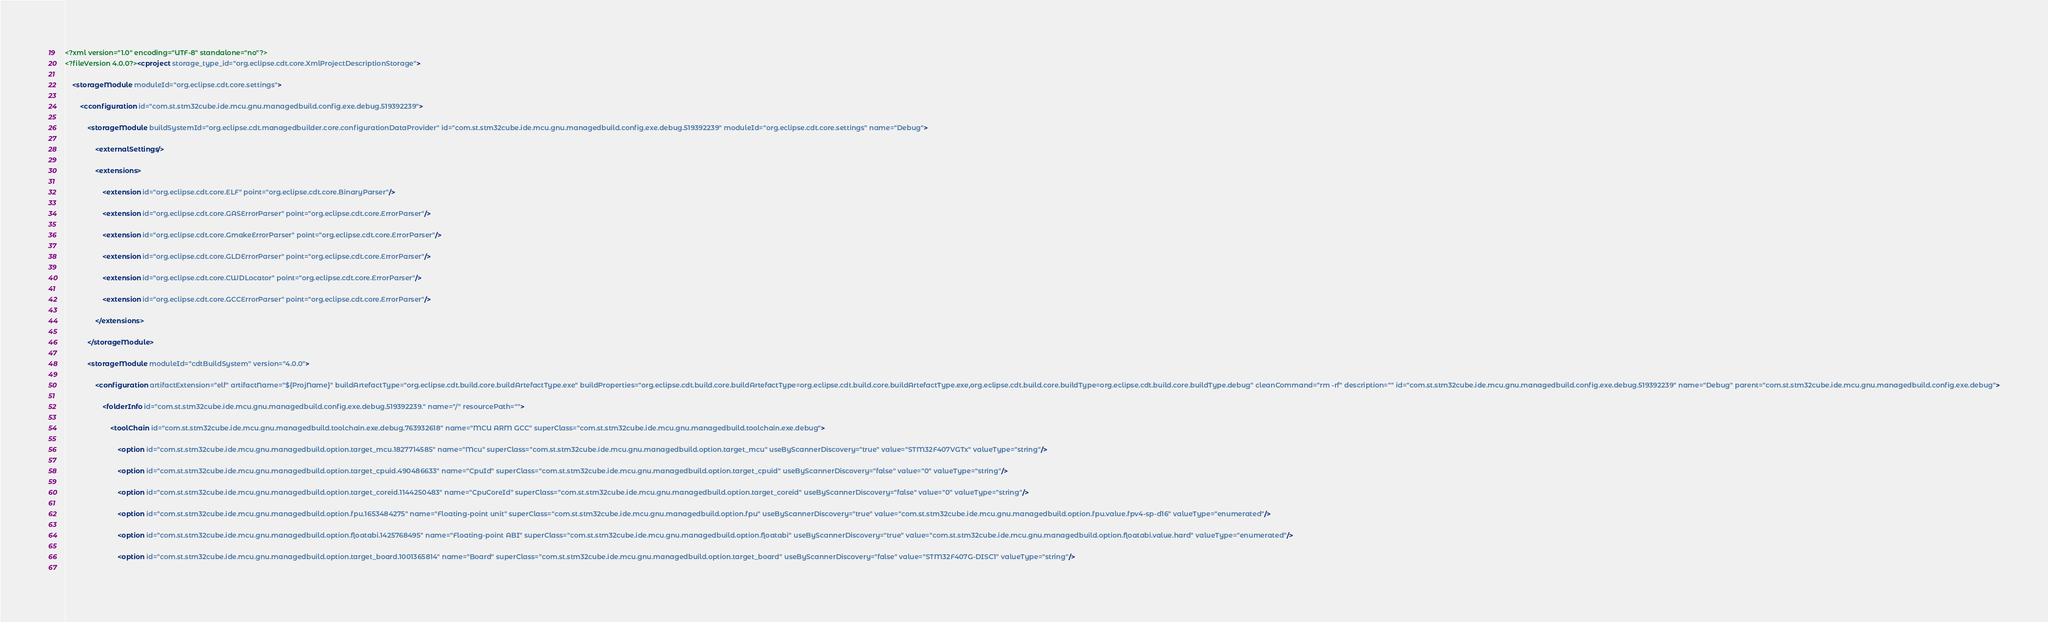Convert code to text. <code><loc_0><loc_0><loc_500><loc_500><_XML_><?xml version="1.0" encoding="UTF-8" standalone="no"?>
<?fileVersion 4.0.0?><cproject storage_type_id="org.eclipse.cdt.core.XmlProjectDescriptionStorage">
    	
    <storageModule moduleId="org.eclipse.cdt.core.settings">
        		
        <cconfiguration id="com.st.stm32cube.ide.mcu.gnu.managedbuild.config.exe.debug.519392239">
            			
            <storageModule buildSystemId="org.eclipse.cdt.managedbuilder.core.configurationDataProvider" id="com.st.stm32cube.ide.mcu.gnu.managedbuild.config.exe.debug.519392239" moduleId="org.eclipse.cdt.core.settings" name="Debug">
                				
                <externalSettings/>
                				
                <extensions>
                    					
                    <extension id="org.eclipse.cdt.core.ELF" point="org.eclipse.cdt.core.BinaryParser"/>
                    					
                    <extension id="org.eclipse.cdt.core.GASErrorParser" point="org.eclipse.cdt.core.ErrorParser"/>
                    					
                    <extension id="org.eclipse.cdt.core.GmakeErrorParser" point="org.eclipse.cdt.core.ErrorParser"/>
                    					
                    <extension id="org.eclipse.cdt.core.GLDErrorParser" point="org.eclipse.cdt.core.ErrorParser"/>
                    					
                    <extension id="org.eclipse.cdt.core.CWDLocator" point="org.eclipse.cdt.core.ErrorParser"/>
                    					
                    <extension id="org.eclipse.cdt.core.GCCErrorParser" point="org.eclipse.cdt.core.ErrorParser"/>
                    				
                </extensions>
                			
            </storageModule>
            			
            <storageModule moduleId="cdtBuildSystem" version="4.0.0">
                				
                <configuration artifactExtension="elf" artifactName="${ProjName}" buildArtefactType="org.eclipse.cdt.build.core.buildArtefactType.exe" buildProperties="org.eclipse.cdt.build.core.buildArtefactType=org.eclipse.cdt.build.core.buildArtefactType.exe,org.eclipse.cdt.build.core.buildType=org.eclipse.cdt.build.core.buildType.debug" cleanCommand="rm -rf" description="" id="com.st.stm32cube.ide.mcu.gnu.managedbuild.config.exe.debug.519392239" name="Debug" parent="com.st.stm32cube.ide.mcu.gnu.managedbuild.config.exe.debug">
                    					
                    <folderInfo id="com.st.stm32cube.ide.mcu.gnu.managedbuild.config.exe.debug.519392239." name="/" resourcePath="">
                        						
                        <toolChain id="com.st.stm32cube.ide.mcu.gnu.managedbuild.toolchain.exe.debug.763932618" name="MCU ARM GCC" superClass="com.st.stm32cube.ide.mcu.gnu.managedbuild.toolchain.exe.debug">
                            							
                            <option id="com.st.stm32cube.ide.mcu.gnu.managedbuild.option.target_mcu.1827714585" name="Mcu" superClass="com.st.stm32cube.ide.mcu.gnu.managedbuild.option.target_mcu" useByScannerDiscovery="true" value="STM32F407VGTx" valueType="string"/>
                            							
                            <option id="com.st.stm32cube.ide.mcu.gnu.managedbuild.option.target_cpuid.490486633" name="CpuId" superClass="com.st.stm32cube.ide.mcu.gnu.managedbuild.option.target_cpuid" useByScannerDiscovery="false" value="0" valueType="string"/>
                            							
                            <option id="com.st.stm32cube.ide.mcu.gnu.managedbuild.option.target_coreid.1144250483" name="CpuCoreId" superClass="com.st.stm32cube.ide.mcu.gnu.managedbuild.option.target_coreid" useByScannerDiscovery="false" value="0" valueType="string"/>
                            							
                            <option id="com.st.stm32cube.ide.mcu.gnu.managedbuild.option.fpu.1653484275" name="Floating-point unit" superClass="com.st.stm32cube.ide.mcu.gnu.managedbuild.option.fpu" useByScannerDiscovery="true" value="com.st.stm32cube.ide.mcu.gnu.managedbuild.option.fpu.value.fpv4-sp-d16" valueType="enumerated"/>
                            							
                            <option id="com.st.stm32cube.ide.mcu.gnu.managedbuild.option.floatabi.1425768495" name="Floating-point ABI" superClass="com.st.stm32cube.ide.mcu.gnu.managedbuild.option.floatabi" useByScannerDiscovery="true" value="com.st.stm32cube.ide.mcu.gnu.managedbuild.option.floatabi.value.hard" valueType="enumerated"/>
                            							
                            <option id="com.st.stm32cube.ide.mcu.gnu.managedbuild.option.target_board.1001365814" name="Board" superClass="com.st.stm32cube.ide.mcu.gnu.managedbuild.option.target_board" useByScannerDiscovery="false" value="STM32F407G-DISC1" valueType="string"/>
                            							</code> 